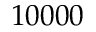<formula> <loc_0><loc_0><loc_500><loc_500>1 0 0 0 0</formula> 